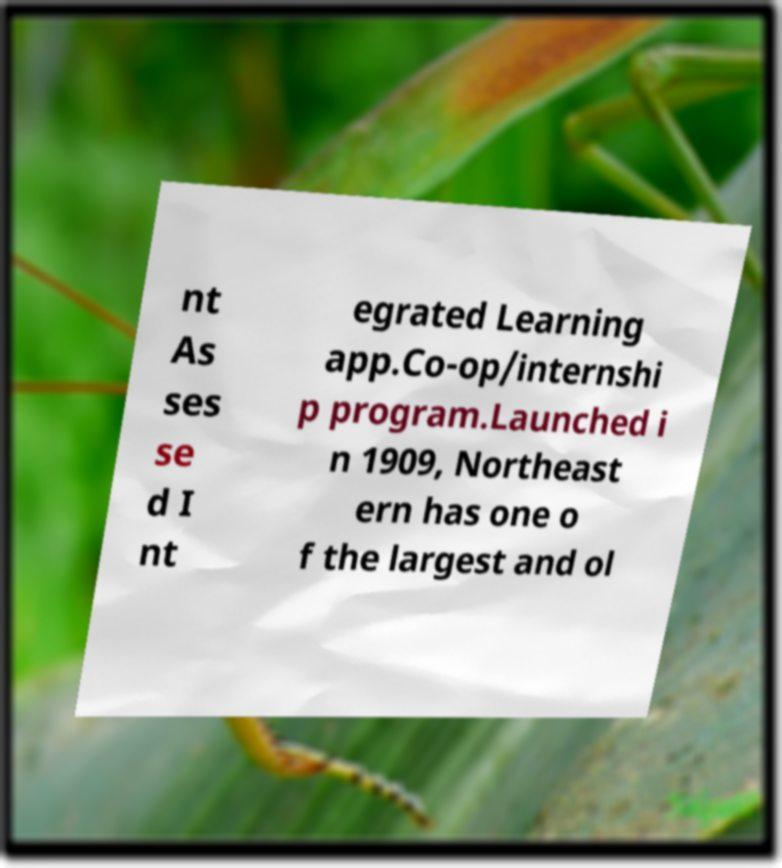There's text embedded in this image that I need extracted. Can you transcribe it verbatim? nt As ses se d I nt egrated Learning app.Co-op/internshi p program.Launched i n 1909, Northeast ern has one o f the largest and ol 